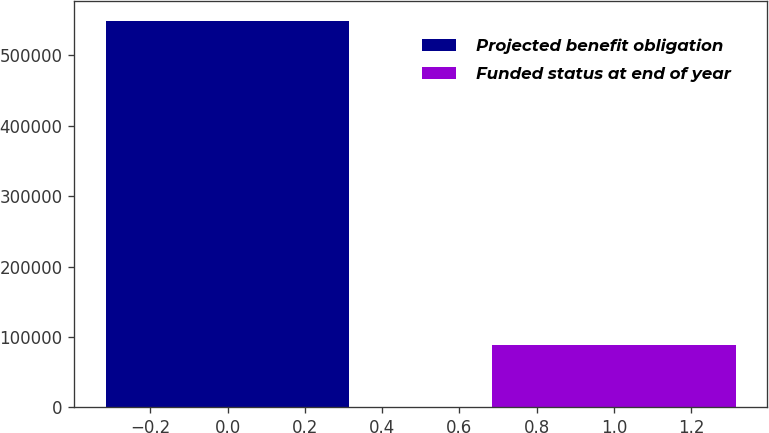<chart> <loc_0><loc_0><loc_500><loc_500><bar_chart><fcel>Projected benefit obligation<fcel>Funded status at end of year<nl><fcel>548938<fcel>87977<nl></chart> 